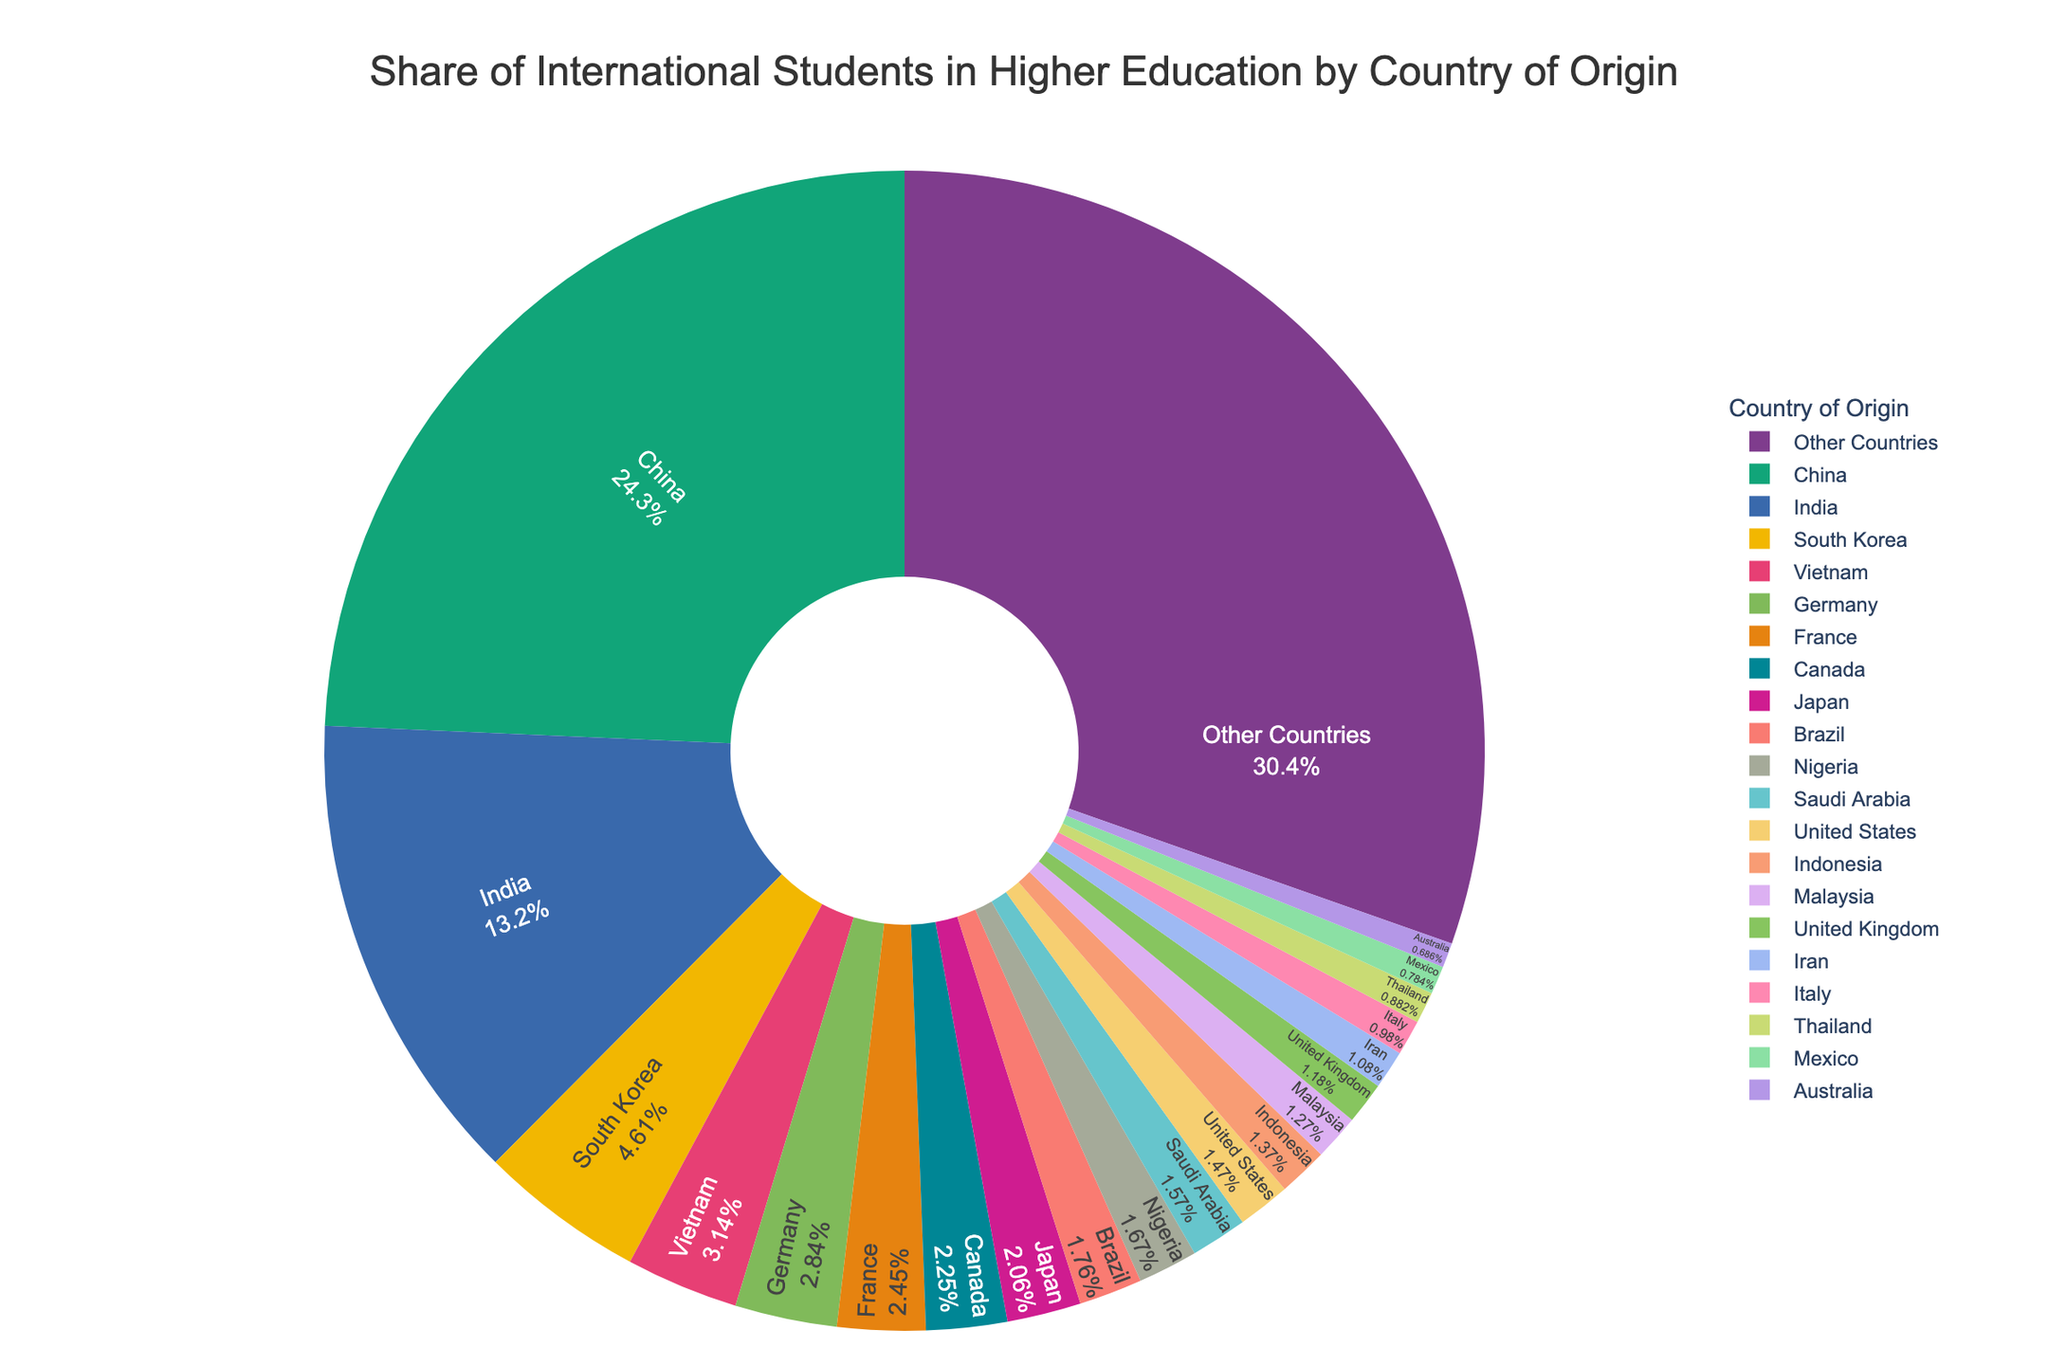What percentage of international students come from China? Locate the slice in the pie chart labeled "China" and read the percentage associated with it.
Answer: 24.8% How many countries have a share of international students greater than 4%? Identify the slices in the pie chart where the share is greater than 4% and count them. The countries are China and India.
Answer: 2 Which country of origin contributes the smallest share of international students? Find the slice in the pie chart with the smallest percentage, not including the "Other Countries" category. This is Australia.
Answer: Australia What is the combined share of international students from Nigeria and Saudi Arabia? Add the percentages of international students from Nigeria and Saudi Arabia, which are 1.7% and 1.6%, respectively.
Answer: 3.3% Is the share of international students from India greater than the share from all European countries combined? Sum the percentages of European countries (Germany 2.9%, France 2.5%, United Kingdom 1.2%, and Italy 1.0%) and compare it with India's share (13.5%). The combined percentage of European countries is 7.6%.
Answer: Yes What is the share of international students from "Other Countries"? Locate the slice in the pie chart labeled "Other Countries" and read the percentage associated with it.
Answer: 31.0% How does the share of students from Vietnam compare to that from South Korea? Locate the slices for Vietnam and South Korea. Vietnam has 3.2%, while South Korea has 4.7%.
Answer: South Korea has a higher share What is the difference in the share of international students between Brazil and Mexico? Subtract the percentage for Mexico (0.8%) from the percentage for Brazil (1.8%).
Answer: 1.0% What is the combined share of the top three countries of origin? Add the percentages of the top three countries of origin: China (24.8%), India (13.5%), and South Korea (4.7%).
Answer: 43.0% How does the share of international students from the United States compare to that from Canada? Locate the slices for the United States (1.5%) and Canada (2.3%) and compare them.
Answer: Canada has a higher share 